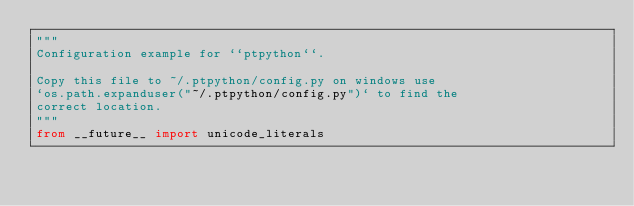Convert code to text. <code><loc_0><loc_0><loc_500><loc_500><_Python_>"""
Configuration example for ``ptpython``.

Copy this file to ~/.ptpython/config.py on windows use 
`os.path.expanduser("~/.ptpython/config.py")` to find the 
correct location.
"""
from __future__ import unicode_literals</code> 